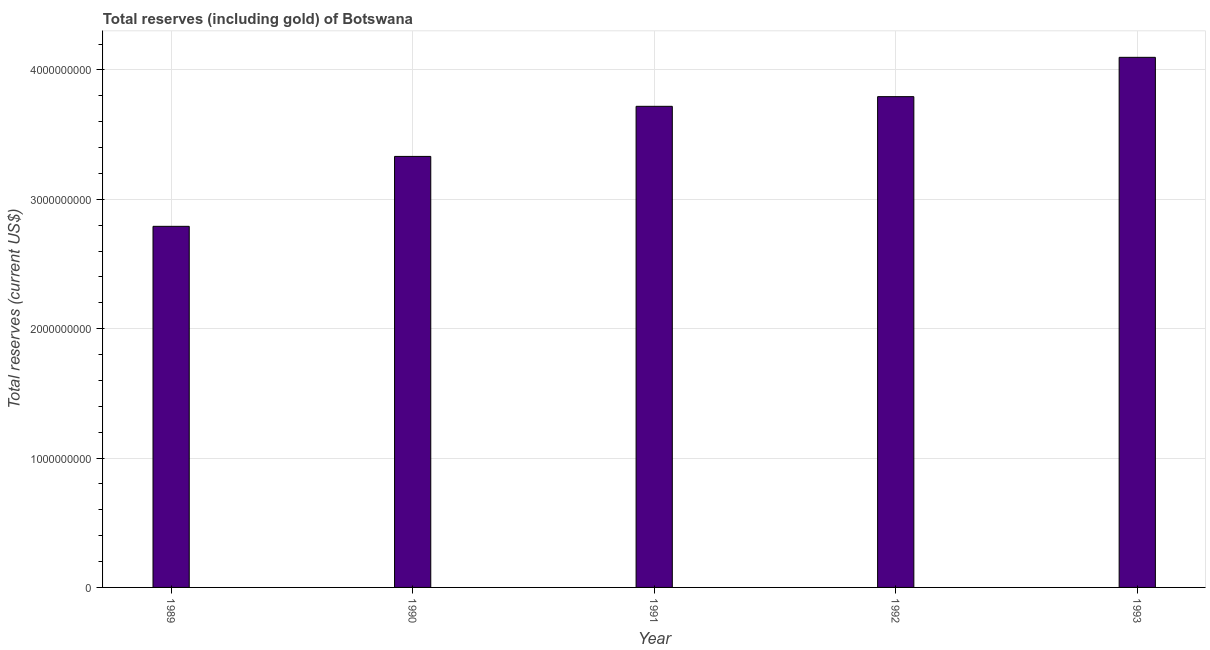Does the graph contain any zero values?
Offer a terse response. No. Does the graph contain grids?
Keep it short and to the point. Yes. What is the title of the graph?
Offer a very short reply. Total reserves (including gold) of Botswana. What is the label or title of the X-axis?
Keep it short and to the point. Year. What is the label or title of the Y-axis?
Offer a very short reply. Total reserves (current US$). What is the total reserves (including gold) in 1993?
Provide a succinct answer. 4.10e+09. Across all years, what is the maximum total reserves (including gold)?
Your answer should be very brief. 4.10e+09. Across all years, what is the minimum total reserves (including gold)?
Provide a succinct answer. 2.79e+09. In which year was the total reserves (including gold) maximum?
Provide a short and direct response. 1993. What is the sum of the total reserves (including gold)?
Ensure brevity in your answer.  1.77e+1. What is the difference between the total reserves (including gold) in 1989 and 1993?
Your response must be concise. -1.31e+09. What is the average total reserves (including gold) per year?
Keep it short and to the point. 3.55e+09. What is the median total reserves (including gold)?
Your answer should be compact. 3.72e+09. In how many years, is the total reserves (including gold) greater than 400000000 US$?
Offer a very short reply. 5. Do a majority of the years between 1991 and 1990 (inclusive) have total reserves (including gold) greater than 4000000000 US$?
Make the answer very short. No. What is the ratio of the total reserves (including gold) in 1989 to that in 1990?
Your answer should be very brief. 0.84. What is the difference between the highest and the second highest total reserves (including gold)?
Keep it short and to the point. 3.04e+08. What is the difference between the highest and the lowest total reserves (including gold)?
Your answer should be very brief. 1.31e+09. How many bars are there?
Provide a succinct answer. 5. How many years are there in the graph?
Offer a terse response. 5. Are the values on the major ticks of Y-axis written in scientific E-notation?
Provide a succinct answer. No. What is the Total reserves (current US$) of 1989?
Your answer should be compact. 2.79e+09. What is the Total reserves (current US$) of 1990?
Offer a very short reply. 3.33e+09. What is the Total reserves (current US$) of 1991?
Offer a terse response. 3.72e+09. What is the Total reserves (current US$) in 1992?
Your answer should be compact. 3.79e+09. What is the Total reserves (current US$) in 1993?
Your answer should be compact. 4.10e+09. What is the difference between the Total reserves (current US$) in 1989 and 1990?
Make the answer very short. -5.40e+08. What is the difference between the Total reserves (current US$) in 1989 and 1991?
Offer a terse response. -9.28e+08. What is the difference between the Total reserves (current US$) in 1989 and 1992?
Keep it short and to the point. -1.00e+09. What is the difference between the Total reserves (current US$) in 1989 and 1993?
Your response must be concise. -1.31e+09. What is the difference between the Total reserves (current US$) in 1990 and 1991?
Offer a very short reply. -3.87e+08. What is the difference between the Total reserves (current US$) in 1990 and 1992?
Make the answer very short. -4.62e+08. What is the difference between the Total reserves (current US$) in 1990 and 1993?
Ensure brevity in your answer.  -7.66e+08. What is the difference between the Total reserves (current US$) in 1991 and 1992?
Your answer should be compact. -7.48e+07. What is the difference between the Total reserves (current US$) in 1991 and 1993?
Your response must be concise. -3.79e+08. What is the difference between the Total reserves (current US$) in 1992 and 1993?
Ensure brevity in your answer.  -3.04e+08. What is the ratio of the Total reserves (current US$) in 1989 to that in 1990?
Your answer should be compact. 0.84. What is the ratio of the Total reserves (current US$) in 1989 to that in 1991?
Give a very brief answer. 0.75. What is the ratio of the Total reserves (current US$) in 1989 to that in 1992?
Make the answer very short. 0.74. What is the ratio of the Total reserves (current US$) in 1989 to that in 1993?
Ensure brevity in your answer.  0.68. What is the ratio of the Total reserves (current US$) in 1990 to that in 1991?
Your answer should be compact. 0.9. What is the ratio of the Total reserves (current US$) in 1990 to that in 1992?
Your answer should be compact. 0.88. What is the ratio of the Total reserves (current US$) in 1990 to that in 1993?
Your response must be concise. 0.81. What is the ratio of the Total reserves (current US$) in 1991 to that in 1993?
Give a very brief answer. 0.91. What is the ratio of the Total reserves (current US$) in 1992 to that in 1993?
Your response must be concise. 0.93. 